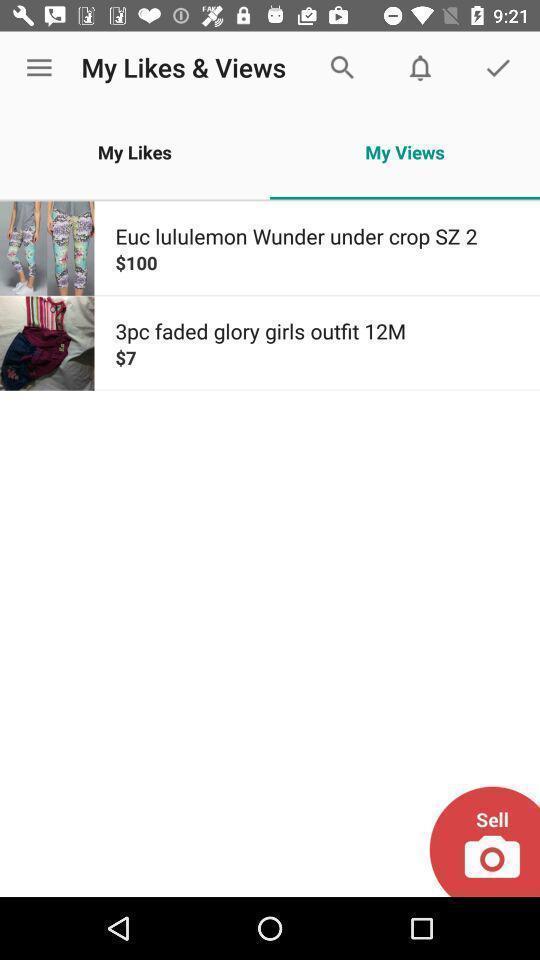Provide a detailed account of this screenshot. Screen showing my views. 